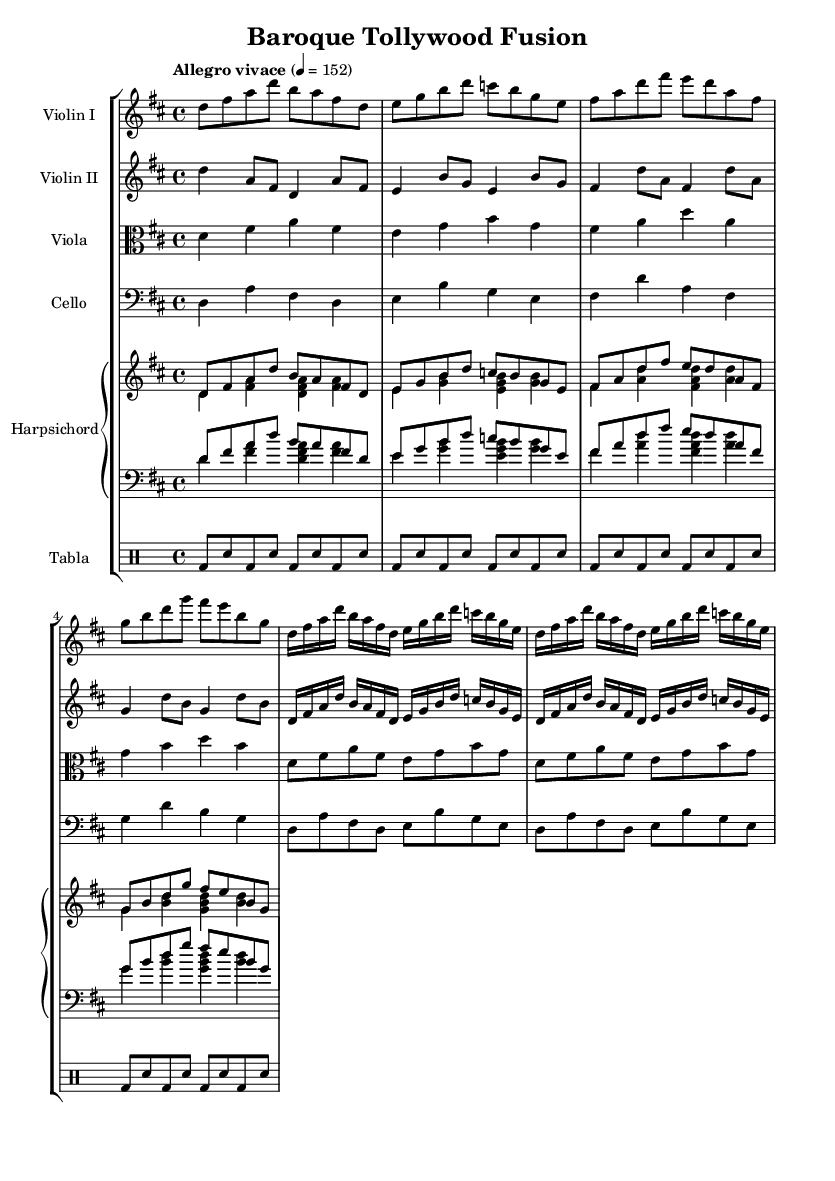What is the key signature of this music? The key signature shows two sharps, which indicates that the key of this piece is D major.
Answer: D major What is the time signature of this music? The time signature displayed in the sheet music is 4/4, meaning there are four beats in each measure.
Answer: 4/4 What is the tempo marking of this piece? The tempo marking indicates "Allegro vivace," which describes a fast and lively pace for the music, set at 152 beats per minute.
Answer: Allegro vivace How many measures are repeated in the strings? The sheet music indicates that the section for the strings (Violin I, Violin II, Viola, Cello) has a "repeat unfold" instruction that means a two-measure section is repeated twice.
Answer: 2 measures Which instruments are used in this ensemble? The ensemble consists of Violin I, Violin II, Viola, Cello, Harpsichord, and Tabla, showcasing a mix of strings, keyboard, and percussion instruments typical in Baroque compositions.
Answer: Violin, Viola, Cello, Harpsichord, Tabla What type of rhythmic pattern is used in the tabla section? The tabla part follows a consistent alternation of bass (bd) and snare (sn) hits in eighth-note patterns, common in many energetic dance styles found in both Baroque and Tollywood music.
Answer: Eighth notes What is the texture of the music? The music features a polyphonic texture, where multiple independent melody lines are played simultaneously, characteristic of Baroque music ensemble arrangements.
Answer: Polyphonic 